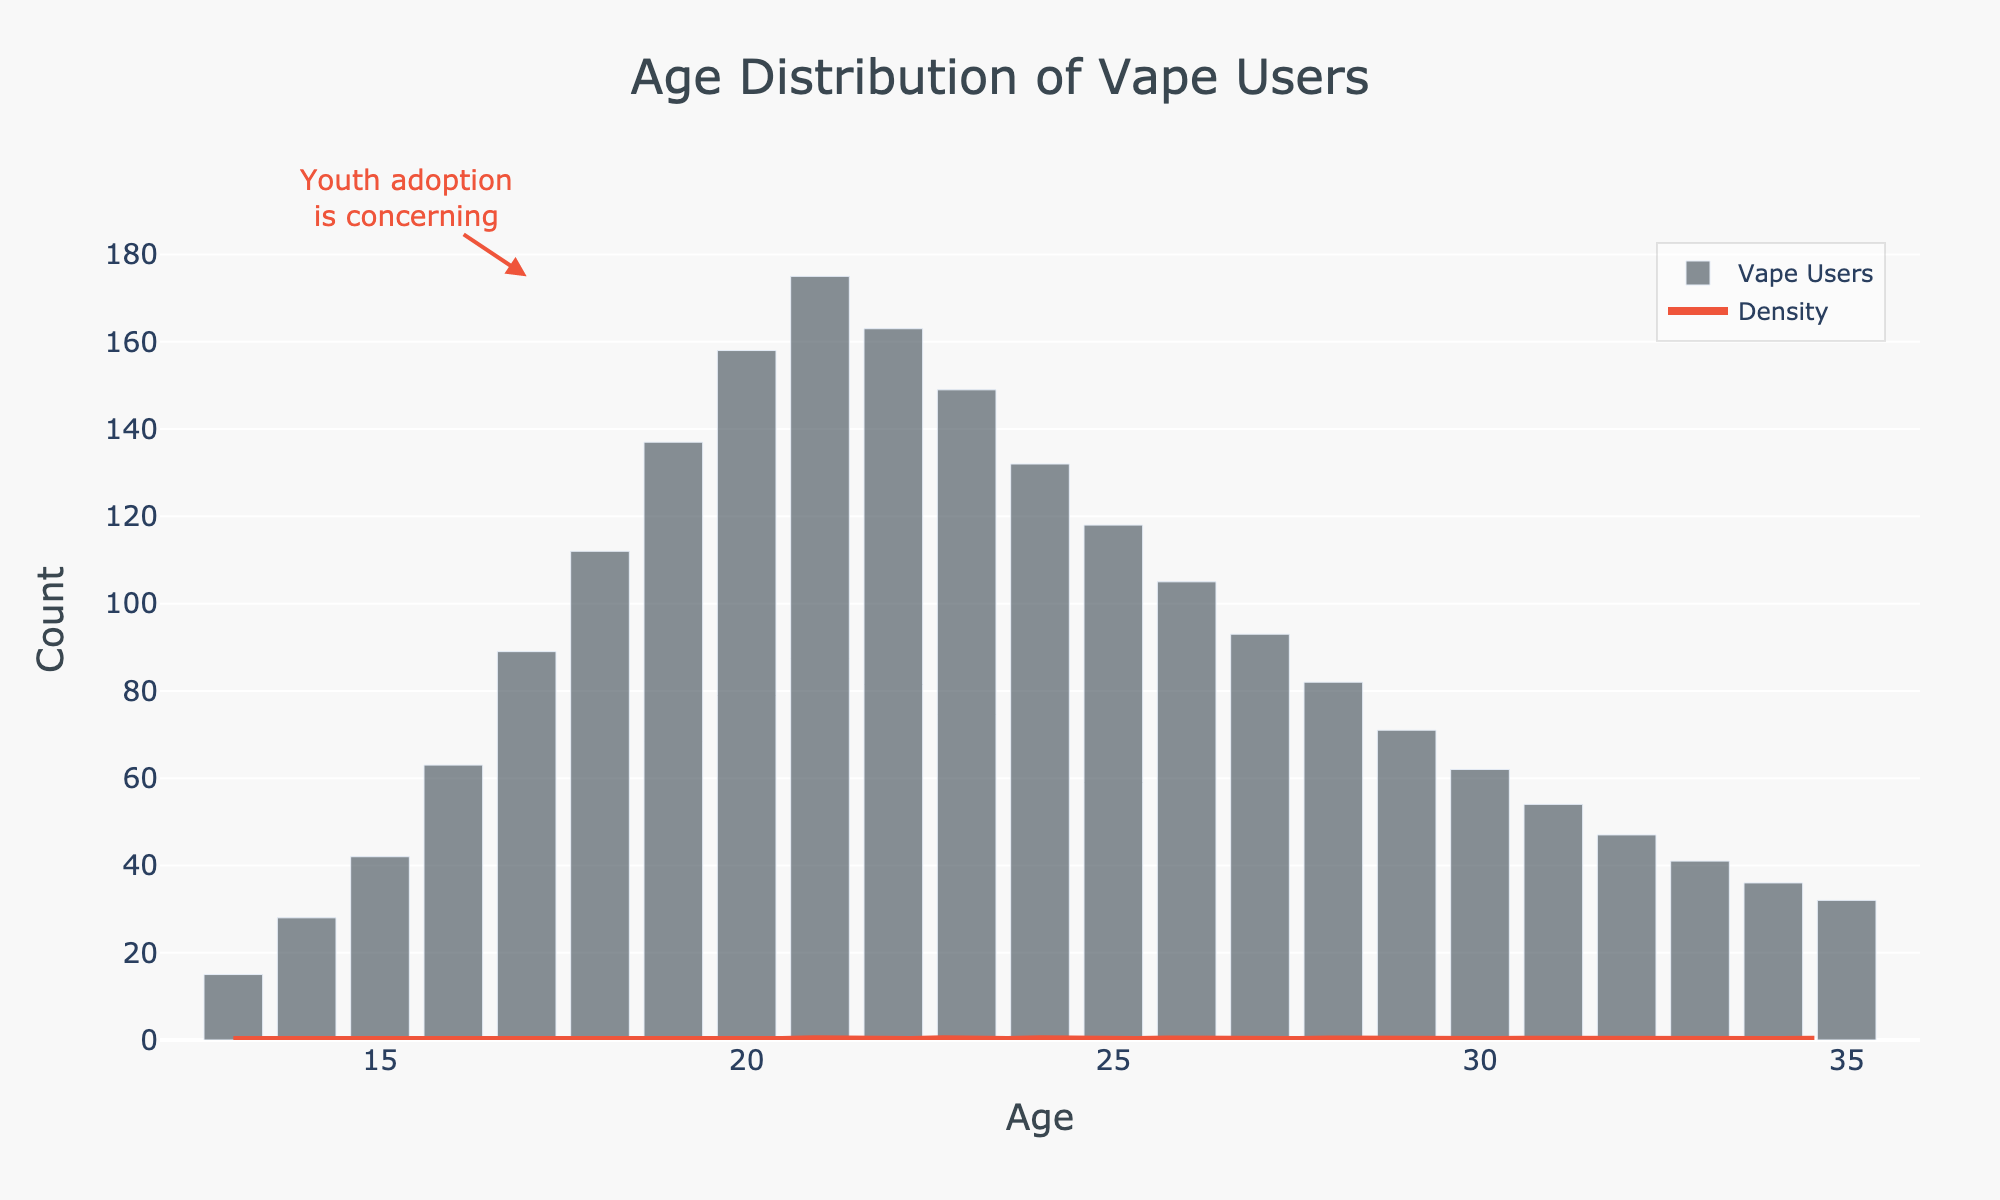What is the age range depicted in the histogram? The x-axis of the histogram shows age distribution from 13 to 35 years, so the age range is from 13 to 35 years.
Answer: 13 to 35 What age has the highest count of vape users? By observing the histogram bars, the age with the highest count is the one that has the tallest bar, which is at age 21.
Answer: 21 How many vape users are there at age 18? By looking at the height of the bar at age 18, we see that it reaches up to 112 users.
Answer: 112 Is there a concerning trend in youth adoption of vaping? The annotation on the histogram points to the age 17 bar with a note stating "Youth adoption is concerning" highlighting that youth usage is significant.
Answer: Yes What is the approximate count of vape users at age 15 and at age 30? Find the bars for ages 15 and 30 and observe their heights. Age 15 has approximately 42 users, and age 30 has approximately 62 users.
Answer: 42 and 62 What is the trend in the number of vape users from age 13 to 21? From age 13 to 21, the histogram shows an increasing trend in the number of vape users. The bars progressively get taller from age 13 to age 21.
Answer: Increasing Which age group has fewer vape users: 13-year-olds or 32-year-olds? Compare the heights of the bars for ages 13 and 32. The 13-year-old group has fewer vape users (15) compared to the 32-year-old group (47).
Answer: 13-year-olds Between which ages is there a significant increase in the density of vape users, as shown by the KDE curve? The KDE curve shows a significant increase in density starting around age 15 and peaking around age 21, indicating higher density within this age range.
Answer: 15 to 21 What age group has the lowest density of vape users according to the KDE curve? The KDE curve is at its lowest density level at the start (age 13) and towards age 35. The lowest density can be observed at age 13.
Answer: Age 13 How does the vape user count change after age 21? After age 21, the height of the bars in the histogram gradually decreases, indicating a decline in the number of vape users.
Answer: Decreases 